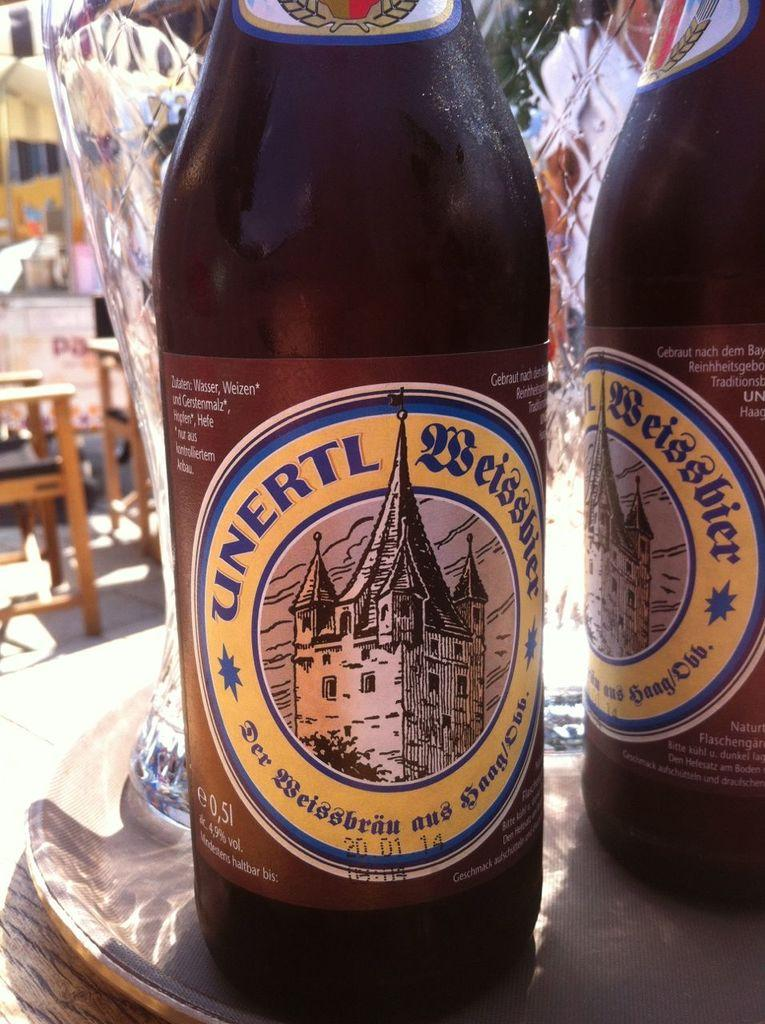<image>
Write a terse but informative summary of the picture. a close up of Unertl drink on a table outside 